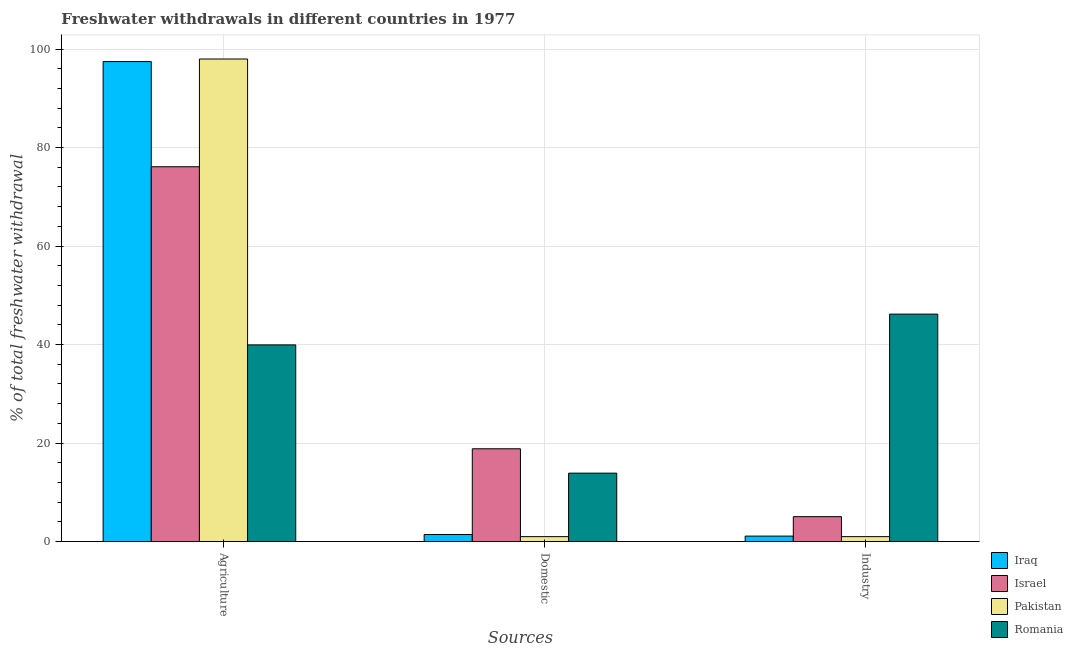How many different coloured bars are there?
Offer a very short reply. 4. How many groups of bars are there?
Make the answer very short. 3. Are the number of bars per tick equal to the number of legend labels?
Keep it short and to the point. Yes. Are the number of bars on each tick of the X-axis equal?
Your answer should be very brief. Yes. How many bars are there on the 1st tick from the left?
Your answer should be compact. 4. What is the label of the 3rd group of bars from the left?
Make the answer very short. Industry. What is the percentage of freshwater withdrawal for domestic purposes in Iraq?
Provide a succinct answer. 1.43. Across all countries, what is the maximum percentage of freshwater withdrawal for domestic purposes?
Keep it short and to the point. 18.84. Across all countries, what is the minimum percentage of freshwater withdrawal for domestic purposes?
Make the answer very short. 1. In which country was the percentage of freshwater withdrawal for agriculture maximum?
Provide a succinct answer. Pakistan. In which country was the percentage of freshwater withdrawal for agriculture minimum?
Keep it short and to the point. Romania. What is the total percentage of freshwater withdrawal for industry in the graph?
Make the answer very short. 53.34. What is the difference between the percentage of freshwater withdrawal for industry in Pakistan and that in Romania?
Ensure brevity in your answer.  -45.18. What is the difference between the percentage of freshwater withdrawal for industry in Israel and the percentage of freshwater withdrawal for domestic purposes in Romania?
Provide a succinct answer. -8.84. What is the average percentage of freshwater withdrawal for domestic purposes per country?
Give a very brief answer. 8.79. What is the difference between the percentage of freshwater withdrawal for industry and percentage of freshwater withdrawal for domestic purposes in Iraq?
Give a very brief answer. -0.32. What is the ratio of the percentage of freshwater withdrawal for agriculture in Israel to that in Pakistan?
Give a very brief answer. 0.78. Is the percentage of freshwater withdrawal for agriculture in Iraq less than that in Israel?
Offer a very short reply. No. Is the difference between the percentage of freshwater withdrawal for industry in Pakistan and Israel greater than the difference between the percentage of freshwater withdrawal for domestic purposes in Pakistan and Israel?
Your answer should be compact. Yes. What is the difference between the highest and the second highest percentage of freshwater withdrawal for industry?
Offer a very short reply. 41.12. What is the difference between the highest and the lowest percentage of freshwater withdrawal for industry?
Provide a short and direct response. 45.18. Is the sum of the percentage of freshwater withdrawal for industry in Romania and Iraq greater than the maximum percentage of freshwater withdrawal for domestic purposes across all countries?
Provide a succinct answer. Yes. What does the 3rd bar from the right in Domestic represents?
Give a very brief answer. Israel. What is the difference between two consecutive major ticks on the Y-axis?
Ensure brevity in your answer.  20. Are the values on the major ticks of Y-axis written in scientific E-notation?
Your answer should be very brief. No. Does the graph contain any zero values?
Offer a terse response. No. What is the title of the graph?
Ensure brevity in your answer.  Freshwater withdrawals in different countries in 1977. What is the label or title of the X-axis?
Offer a terse response. Sources. What is the label or title of the Y-axis?
Your response must be concise. % of total freshwater withdrawal. What is the % of total freshwater withdrawal of Iraq in Agriculture?
Offer a terse response. 97.46. What is the % of total freshwater withdrawal in Israel in Agriculture?
Provide a short and direct response. 76.1. What is the % of total freshwater withdrawal of Pakistan in Agriculture?
Provide a short and direct response. 97.98. What is the % of total freshwater withdrawal of Romania in Agriculture?
Your answer should be very brief. 39.93. What is the % of total freshwater withdrawal in Iraq in Domestic?
Keep it short and to the point. 1.43. What is the % of total freshwater withdrawal in Israel in Domestic?
Keep it short and to the point. 18.84. What is the % of total freshwater withdrawal in Pakistan in Domestic?
Offer a very short reply. 1. What is the % of total freshwater withdrawal in Romania in Domestic?
Keep it short and to the point. 13.89. What is the % of total freshwater withdrawal of Iraq in Industry?
Your answer should be very brief. 1.11. What is the % of total freshwater withdrawal of Israel in Industry?
Make the answer very short. 5.05. What is the % of total freshwater withdrawal in Pakistan in Industry?
Your response must be concise. 1. What is the % of total freshwater withdrawal in Romania in Industry?
Offer a very short reply. 46.18. Across all Sources, what is the maximum % of total freshwater withdrawal of Iraq?
Ensure brevity in your answer.  97.46. Across all Sources, what is the maximum % of total freshwater withdrawal of Israel?
Offer a terse response. 76.1. Across all Sources, what is the maximum % of total freshwater withdrawal in Pakistan?
Give a very brief answer. 97.98. Across all Sources, what is the maximum % of total freshwater withdrawal in Romania?
Give a very brief answer. 46.18. Across all Sources, what is the minimum % of total freshwater withdrawal in Iraq?
Your answer should be very brief. 1.11. Across all Sources, what is the minimum % of total freshwater withdrawal in Israel?
Keep it short and to the point. 5.05. Across all Sources, what is the minimum % of total freshwater withdrawal of Pakistan?
Provide a short and direct response. 1. Across all Sources, what is the minimum % of total freshwater withdrawal in Romania?
Provide a short and direct response. 13.89. What is the total % of total freshwater withdrawal of Iraq in the graph?
Make the answer very short. 100. What is the total % of total freshwater withdrawal of Israel in the graph?
Provide a short and direct response. 100. What is the total % of total freshwater withdrawal of Pakistan in the graph?
Make the answer very short. 99.98. What is the total % of total freshwater withdrawal in Romania in the graph?
Give a very brief answer. 100. What is the difference between the % of total freshwater withdrawal of Iraq in Agriculture and that in Domestic?
Provide a short and direct response. 96.03. What is the difference between the % of total freshwater withdrawal of Israel in Agriculture and that in Domestic?
Make the answer very short. 57.26. What is the difference between the % of total freshwater withdrawal in Pakistan in Agriculture and that in Domestic?
Offer a very short reply. 96.98. What is the difference between the % of total freshwater withdrawal of Romania in Agriculture and that in Domestic?
Give a very brief answer. 26.04. What is the difference between the % of total freshwater withdrawal in Iraq in Agriculture and that in Industry?
Provide a short and direct response. 96.35. What is the difference between the % of total freshwater withdrawal in Israel in Agriculture and that in Industry?
Provide a succinct answer. 71.05. What is the difference between the % of total freshwater withdrawal of Pakistan in Agriculture and that in Industry?
Make the answer very short. 96.98. What is the difference between the % of total freshwater withdrawal of Romania in Agriculture and that in Industry?
Ensure brevity in your answer.  -6.25. What is the difference between the % of total freshwater withdrawal of Iraq in Domestic and that in Industry?
Ensure brevity in your answer.  0.32. What is the difference between the % of total freshwater withdrawal of Israel in Domestic and that in Industry?
Your answer should be compact. 13.79. What is the difference between the % of total freshwater withdrawal in Pakistan in Domestic and that in Industry?
Provide a succinct answer. 0. What is the difference between the % of total freshwater withdrawal of Romania in Domestic and that in Industry?
Your answer should be very brief. -32.29. What is the difference between the % of total freshwater withdrawal in Iraq in Agriculture and the % of total freshwater withdrawal in Israel in Domestic?
Your answer should be very brief. 78.62. What is the difference between the % of total freshwater withdrawal in Iraq in Agriculture and the % of total freshwater withdrawal in Pakistan in Domestic?
Offer a very short reply. 96.46. What is the difference between the % of total freshwater withdrawal in Iraq in Agriculture and the % of total freshwater withdrawal in Romania in Domestic?
Your response must be concise. 83.57. What is the difference between the % of total freshwater withdrawal in Israel in Agriculture and the % of total freshwater withdrawal in Pakistan in Domestic?
Provide a succinct answer. 75.1. What is the difference between the % of total freshwater withdrawal of Israel in Agriculture and the % of total freshwater withdrawal of Romania in Domestic?
Your response must be concise. 62.21. What is the difference between the % of total freshwater withdrawal in Pakistan in Agriculture and the % of total freshwater withdrawal in Romania in Domestic?
Provide a succinct answer. 84.09. What is the difference between the % of total freshwater withdrawal of Iraq in Agriculture and the % of total freshwater withdrawal of Israel in Industry?
Provide a succinct answer. 92.41. What is the difference between the % of total freshwater withdrawal of Iraq in Agriculture and the % of total freshwater withdrawal of Pakistan in Industry?
Provide a succinct answer. 96.46. What is the difference between the % of total freshwater withdrawal of Iraq in Agriculture and the % of total freshwater withdrawal of Romania in Industry?
Give a very brief answer. 51.28. What is the difference between the % of total freshwater withdrawal in Israel in Agriculture and the % of total freshwater withdrawal in Pakistan in Industry?
Provide a short and direct response. 75.1. What is the difference between the % of total freshwater withdrawal of Israel in Agriculture and the % of total freshwater withdrawal of Romania in Industry?
Provide a short and direct response. 29.92. What is the difference between the % of total freshwater withdrawal in Pakistan in Agriculture and the % of total freshwater withdrawal in Romania in Industry?
Make the answer very short. 51.8. What is the difference between the % of total freshwater withdrawal of Iraq in Domestic and the % of total freshwater withdrawal of Israel in Industry?
Ensure brevity in your answer.  -3.62. What is the difference between the % of total freshwater withdrawal in Iraq in Domestic and the % of total freshwater withdrawal in Pakistan in Industry?
Provide a short and direct response. 0.43. What is the difference between the % of total freshwater withdrawal of Iraq in Domestic and the % of total freshwater withdrawal of Romania in Industry?
Keep it short and to the point. -44.75. What is the difference between the % of total freshwater withdrawal in Israel in Domestic and the % of total freshwater withdrawal in Pakistan in Industry?
Your answer should be very brief. 17.84. What is the difference between the % of total freshwater withdrawal of Israel in Domestic and the % of total freshwater withdrawal of Romania in Industry?
Keep it short and to the point. -27.34. What is the difference between the % of total freshwater withdrawal in Pakistan in Domestic and the % of total freshwater withdrawal in Romania in Industry?
Give a very brief answer. -45.18. What is the average % of total freshwater withdrawal in Iraq per Sources?
Offer a very short reply. 33.33. What is the average % of total freshwater withdrawal of Israel per Sources?
Your response must be concise. 33.33. What is the average % of total freshwater withdrawal of Pakistan per Sources?
Give a very brief answer. 33.33. What is the average % of total freshwater withdrawal in Romania per Sources?
Offer a very short reply. 33.33. What is the difference between the % of total freshwater withdrawal of Iraq and % of total freshwater withdrawal of Israel in Agriculture?
Your answer should be compact. 21.36. What is the difference between the % of total freshwater withdrawal in Iraq and % of total freshwater withdrawal in Pakistan in Agriculture?
Make the answer very short. -0.52. What is the difference between the % of total freshwater withdrawal in Iraq and % of total freshwater withdrawal in Romania in Agriculture?
Your answer should be very brief. 57.53. What is the difference between the % of total freshwater withdrawal in Israel and % of total freshwater withdrawal in Pakistan in Agriculture?
Offer a terse response. -21.88. What is the difference between the % of total freshwater withdrawal of Israel and % of total freshwater withdrawal of Romania in Agriculture?
Provide a succinct answer. 36.17. What is the difference between the % of total freshwater withdrawal of Pakistan and % of total freshwater withdrawal of Romania in Agriculture?
Your response must be concise. 58.05. What is the difference between the % of total freshwater withdrawal of Iraq and % of total freshwater withdrawal of Israel in Domestic?
Your answer should be compact. -17.41. What is the difference between the % of total freshwater withdrawal in Iraq and % of total freshwater withdrawal in Pakistan in Domestic?
Give a very brief answer. 0.43. What is the difference between the % of total freshwater withdrawal of Iraq and % of total freshwater withdrawal of Romania in Domestic?
Make the answer very short. -12.46. What is the difference between the % of total freshwater withdrawal of Israel and % of total freshwater withdrawal of Pakistan in Domestic?
Provide a succinct answer. 17.84. What is the difference between the % of total freshwater withdrawal of Israel and % of total freshwater withdrawal of Romania in Domestic?
Your answer should be very brief. 4.95. What is the difference between the % of total freshwater withdrawal of Pakistan and % of total freshwater withdrawal of Romania in Domestic?
Give a very brief answer. -12.89. What is the difference between the % of total freshwater withdrawal of Iraq and % of total freshwater withdrawal of Israel in Industry?
Your response must be concise. -3.95. What is the difference between the % of total freshwater withdrawal of Iraq and % of total freshwater withdrawal of Pakistan in Industry?
Offer a very short reply. 0.11. What is the difference between the % of total freshwater withdrawal of Iraq and % of total freshwater withdrawal of Romania in Industry?
Keep it short and to the point. -45.07. What is the difference between the % of total freshwater withdrawal of Israel and % of total freshwater withdrawal of Pakistan in Industry?
Your answer should be very brief. 4.05. What is the difference between the % of total freshwater withdrawal in Israel and % of total freshwater withdrawal in Romania in Industry?
Make the answer very short. -41.12. What is the difference between the % of total freshwater withdrawal of Pakistan and % of total freshwater withdrawal of Romania in Industry?
Your answer should be very brief. -45.18. What is the ratio of the % of total freshwater withdrawal of Iraq in Agriculture to that in Domestic?
Your answer should be compact. 68.15. What is the ratio of the % of total freshwater withdrawal of Israel in Agriculture to that in Domestic?
Your response must be concise. 4.04. What is the ratio of the % of total freshwater withdrawal of Pakistan in Agriculture to that in Domestic?
Provide a short and direct response. 97.98. What is the ratio of the % of total freshwater withdrawal in Romania in Agriculture to that in Domestic?
Ensure brevity in your answer.  2.87. What is the ratio of the % of total freshwater withdrawal in Iraq in Agriculture to that in Industry?
Provide a short and direct response. 87.88. What is the ratio of the % of total freshwater withdrawal in Israel in Agriculture to that in Industry?
Offer a terse response. 15.05. What is the ratio of the % of total freshwater withdrawal of Pakistan in Agriculture to that in Industry?
Provide a succinct answer. 97.98. What is the ratio of the % of total freshwater withdrawal in Romania in Agriculture to that in Industry?
Keep it short and to the point. 0.86. What is the ratio of the % of total freshwater withdrawal of Iraq in Domestic to that in Industry?
Ensure brevity in your answer.  1.29. What is the ratio of the % of total freshwater withdrawal of Israel in Domestic to that in Industry?
Your response must be concise. 3.73. What is the ratio of the % of total freshwater withdrawal in Pakistan in Domestic to that in Industry?
Provide a short and direct response. 1. What is the ratio of the % of total freshwater withdrawal in Romania in Domestic to that in Industry?
Your answer should be very brief. 0.3. What is the difference between the highest and the second highest % of total freshwater withdrawal of Iraq?
Make the answer very short. 96.03. What is the difference between the highest and the second highest % of total freshwater withdrawal in Israel?
Keep it short and to the point. 57.26. What is the difference between the highest and the second highest % of total freshwater withdrawal in Pakistan?
Your answer should be very brief. 96.98. What is the difference between the highest and the second highest % of total freshwater withdrawal of Romania?
Keep it short and to the point. 6.25. What is the difference between the highest and the lowest % of total freshwater withdrawal of Iraq?
Offer a terse response. 96.35. What is the difference between the highest and the lowest % of total freshwater withdrawal in Israel?
Make the answer very short. 71.05. What is the difference between the highest and the lowest % of total freshwater withdrawal of Pakistan?
Provide a short and direct response. 96.98. What is the difference between the highest and the lowest % of total freshwater withdrawal of Romania?
Give a very brief answer. 32.29. 